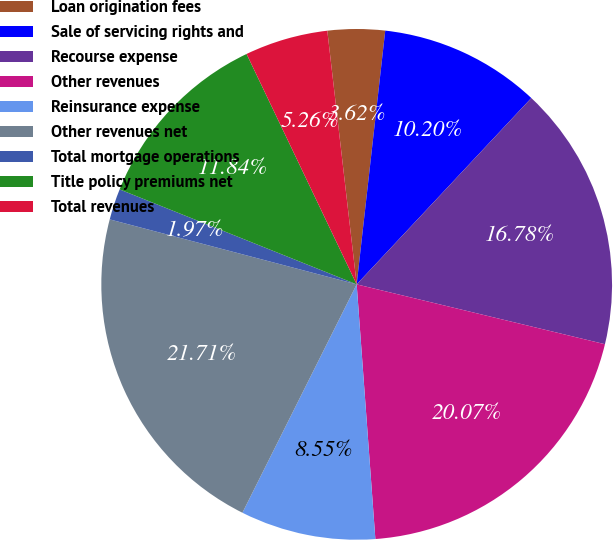Convert chart to OTSL. <chart><loc_0><loc_0><loc_500><loc_500><pie_chart><fcel>Loan origination fees<fcel>Sale of servicing rights and<fcel>Recourse expense<fcel>Other revenues<fcel>Reinsurance expense<fcel>Other revenues net<fcel>Total mortgage operations<fcel>Title policy premiums net<fcel>Total revenues<nl><fcel>3.62%<fcel>10.2%<fcel>16.78%<fcel>20.07%<fcel>8.55%<fcel>21.71%<fcel>1.97%<fcel>11.84%<fcel>5.26%<nl></chart> 